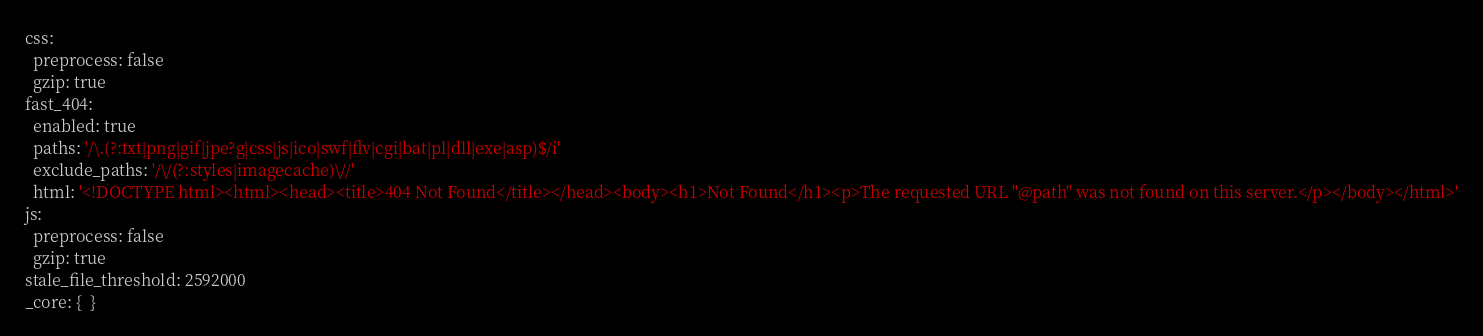<code> <loc_0><loc_0><loc_500><loc_500><_YAML_>css:
  preprocess: false
  gzip: true
fast_404:
  enabled: true
  paths: '/\.(?:txt|png|gif|jpe?g|css|js|ico|swf|flv|cgi|bat|pl|dll|exe|asp)$/i'
  exclude_paths: '/\/(?:styles|imagecache)\//'
  html: '<!DOCTYPE html><html><head><title>404 Not Found</title></head><body><h1>Not Found</h1><p>The requested URL "@path" was not found on this server.</p></body></html>'
js:
  preprocess: false
  gzip: true
stale_file_threshold: 2592000
_core: {  }
</code> 